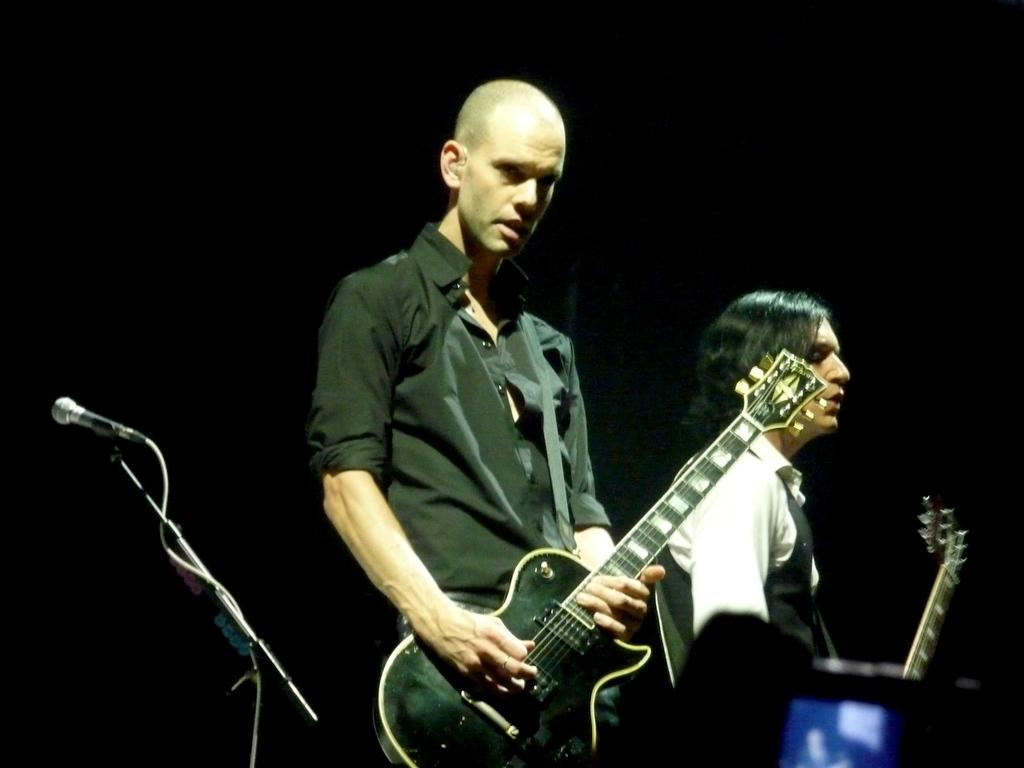How many people are in the image? There are two persons in the image. What are the two persons doing? The two persons are standing and holding guitars. What object related to singing or speaking is present in the image? There is a microphone with a stand in the image. What color is the news report being broadcasted in the image? There is no news report being broadcasted in the image; it features two persons holding guitars and a microphone with a stand. 